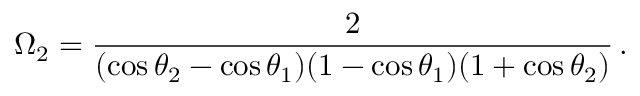Convert formula to latex. <formula><loc_0><loc_0><loc_500><loc_500>\Omega _ { 2 } = \frac { 2 } { ( \cos \theta _ { 2 } - \cos \theta _ { 1 } ) ( 1 - \cos \theta _ { 1 } ) ( 1 + \cos \theta _ { 2 } ) } \, .</formula> 